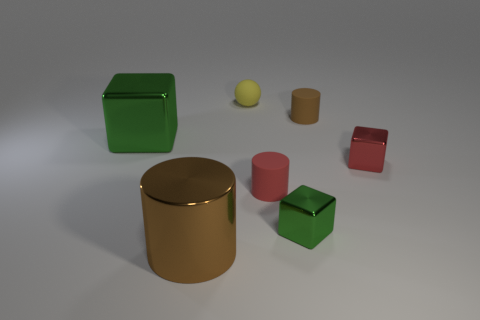Add 3 tiny red objects. How many objects exist? 10 Subtract all blocks. How many objects are left? 4 Subtract all small balls. Subtract all matte cylinders. How many objects are left? 4 Add 3 big metal cubes. How many big metal cubes are left? 4 Add 3 large brown metallic cylinders. How many large brown metallic cylinders exist? 4 Subtract 0 green spheres. How many objects are left? 7 